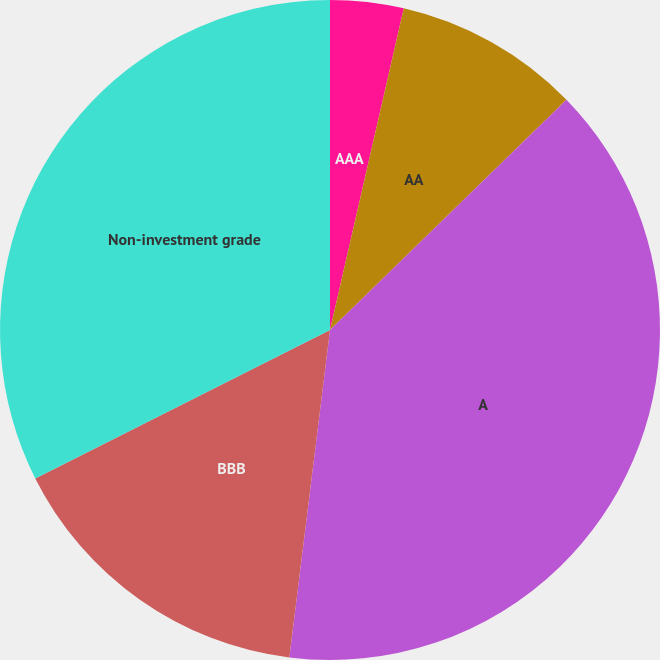Convert chart. <chart><loc_0><loc_0><loc_500><loc_500><pie_chart><fcel>AAA<fcel>AA<fcel>A<fcel>BBB<fcel>Non-investment grade<nl><fcel>3.59%<fcel>9.12%<fcel>39.25%<fcel>15.61%<fcel>32.42%<nl></chart> 